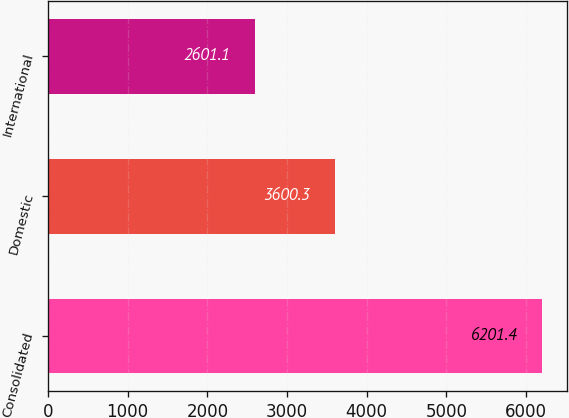<chart> <loc_0><loc_0><loc_500><loc_500><bar_chart><fcel>Consolidated<fcel>Domestic<fcel>International<nl><fcel>6201.4<fcel>3600.3<fcel>2601.1<nl></chart> 